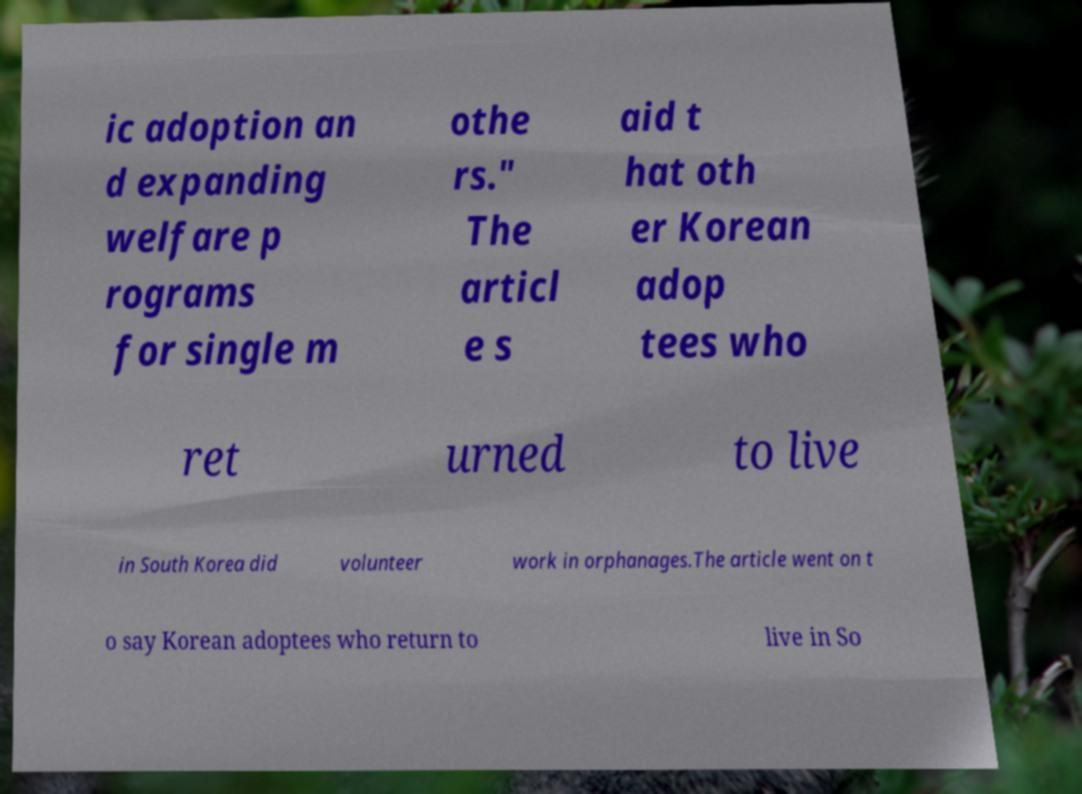For documentation purposes, I need the text within this image transcribed. Could you provide that? ic adoption an d expanding welfare p rograms for single m othe rs." The articl e s aid t hat oth er Korean adop tees who ret urned to live in South Korea did volunteer work in orphanages.The article went on t o say Korean adoptees who return to live in So 